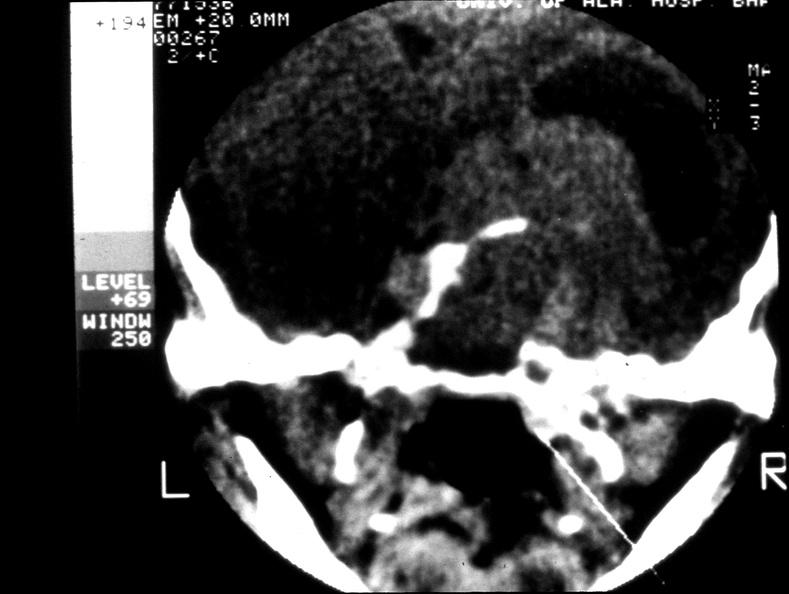does this image show pituitary, chromaphobe adenoma?
Answer the question using a single word or phrase. Yes 